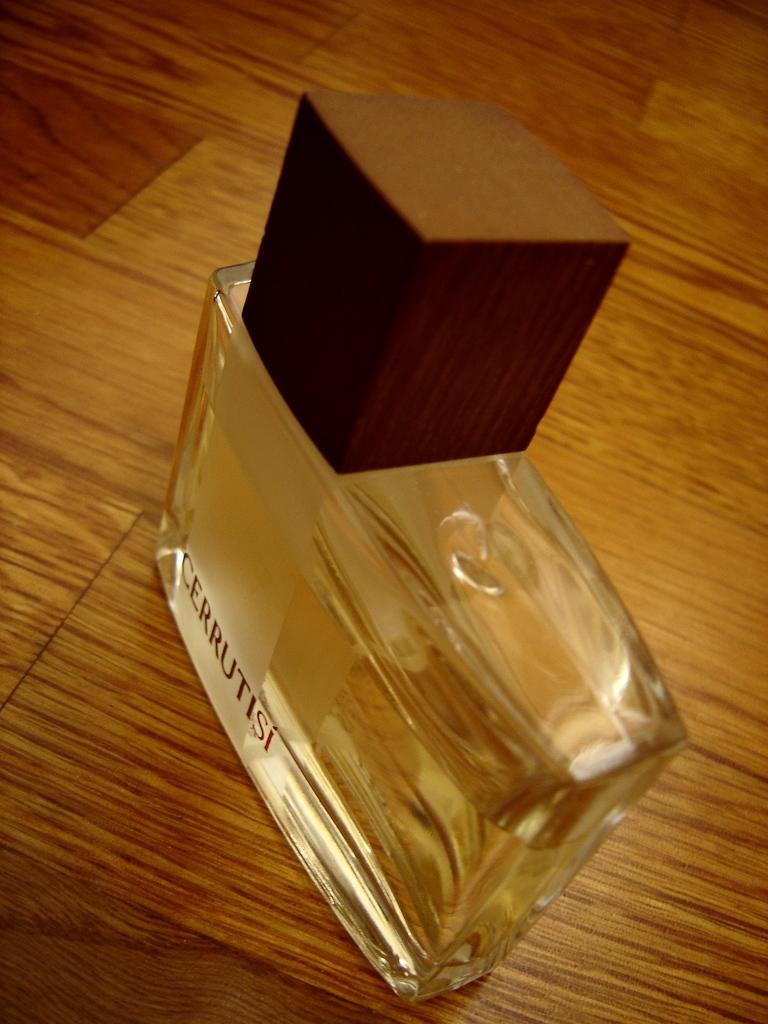<image>
Give a short and clear explanation of the subsequent image. A bottle of Cerrutisi cologne on a laminate table top. 